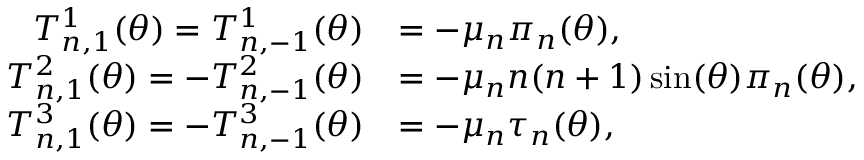Convert formula to latex. <formula><loc_0><loc_0><loc_500><loc_500>\begin{array} { r l } { T _ { n , 1 } ^ { 1 } ( \theta ) = T _ { n , - 1 } ^ { 1 } ( \theta ) } & { = - \mu _ { n } \pi _ { n } ( \theta ) , } \\ { T _ { n , 1 } ^ { 2 } ( \theta ) = - T _ { n , - 1 } ^ { 2 } ( \theta ) } & { = - \mu _ { n } n ( n + 1 ) \sin ( \theta ) \pi _ { n } ( \theta ) , } \\ { T _ { n , 1 } ^ { 3 } ( \theta ) = - T _ { n , - 1 } ^ { 3 } ( \theta ) } & { = - \mu _ { n } \tau _ { n } ( \theta ) , } \end{array}</formula> 